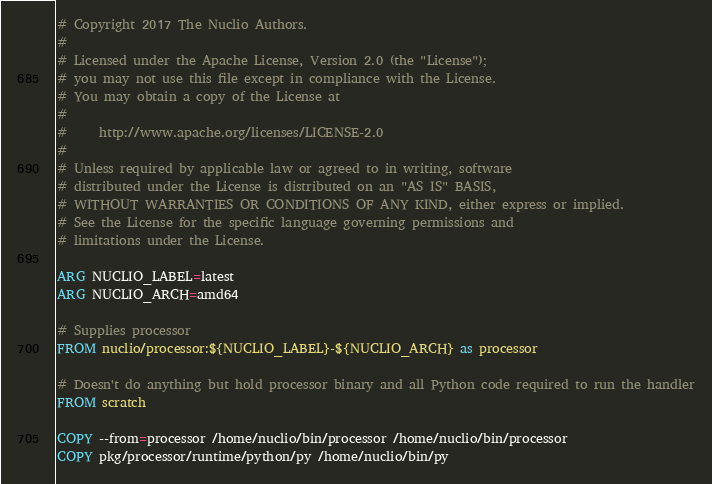<code> <loc_0><loc_0><loc_500><loc_500><_Dockerfile_># Copyright 2017 The Nuclio Authors.
#
# Licensed under the Apache License, Version 2.0 (the "License");
# you may not use this file except in compliance with the License.
# You may obtain a copy of the License at
#
#     http://www.apache.org/licenses/LICENSE-2.0
#
# Unless required by applicable law or agreed to in writing, software
# distributed under the License is distributed on an "AS IS" BASIS,
# WITHOUT WARRANTIES OR CONDITIONS OF ANY KIND, either express or implied.
# See the License for the specific language governing permissions and
# limitations under the License.

ARG NUCLIO_LABEL=latest
ARG NUCLIO_ARCH=amd64

# Supplies processor
FROM nuclio/processor:${NUCLIO_LABEL}-${NUCLIO_ARCH} as processor

# Doesn't do anything but hold processor binary and all Python code required to run the handler
FROM scratch

COPY --from=processor /home/nuclio/bin/processor /home/nuclio/bin/processor
COPY pkg/processor/runtime/python/py /home/nuclio/bin/py
</code> 